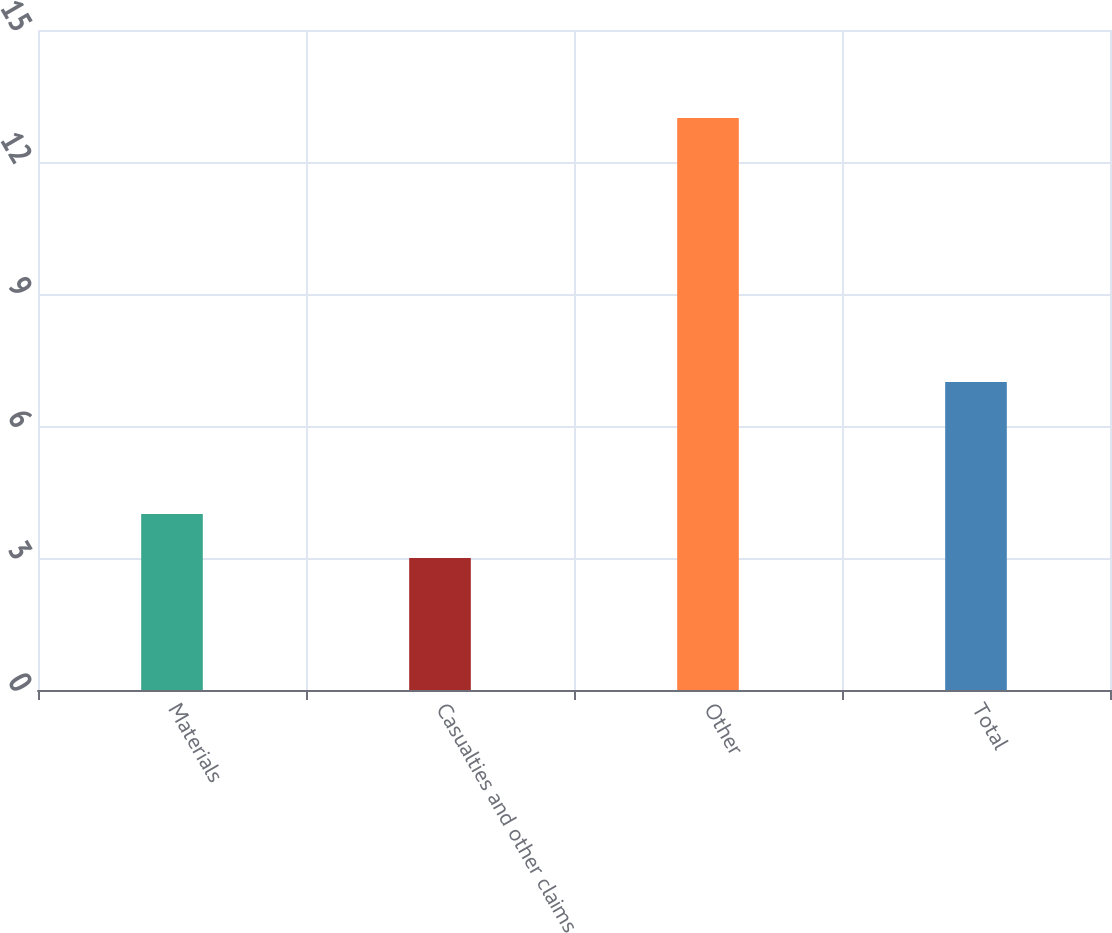Convert chart. <chart><loc_0><loc_0><loc_500><loc_500><bar_chart><fcel>Materials<fcel>Casualties and other claims<fcel>Other<fcel>Total<nl><fcel>4<fcel>3<fcel>13<fcel>7<nl></chart> 